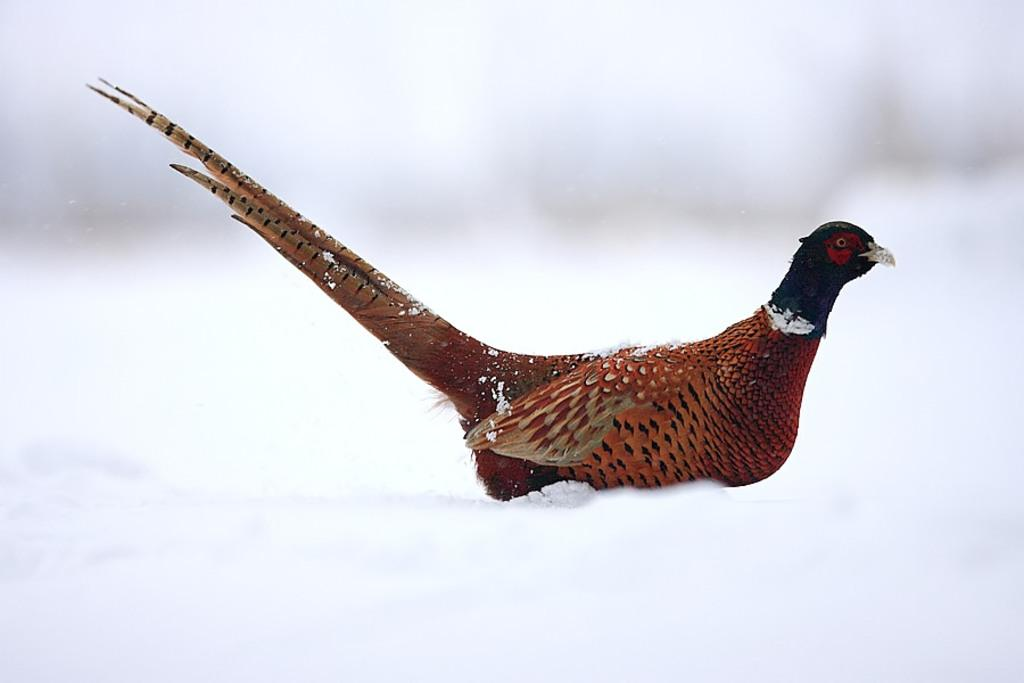What type of animal is in the image? There is a bird in the image. Where is the bird located? The bird is on a white surface. Can you describe the background of the image? The background of the image is blurry and white in color. Can you see the bird's brain in the image? No, the bird's brain is not visible in the image. Is there a throne present in the image? No, there is no throne present in the image. 